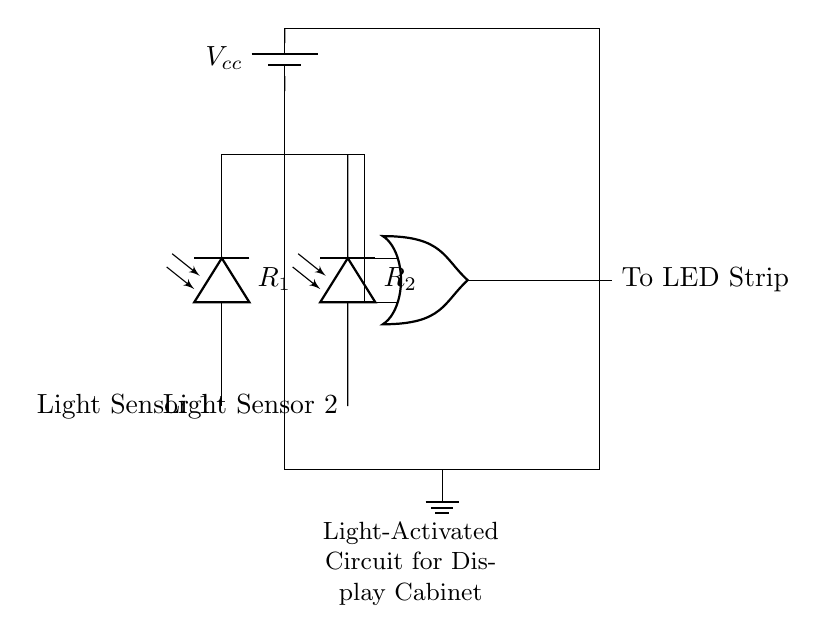What type of sensors are used in this circuit? The circuit uses two light sensors, which are illustrated by photodiodes labeled as Light Sensor 1 and Light Sensor 2. This can be seen in the left section of the diagram where the light sensors are connected to the OR gates.
Answer: photodiodes How many OR gates are in the circuit? The circuit contains one OR gate, which is represented in the center part of the diagram. It receives input from both light sensors.
Answer: one What is the role of the OR gate in this circuit? The OR gate combines the signals from the two light sensors. If either of the sensors detects light, it activates the output to the LED strip. This is a fundamental function of OR gates in logic.
Answer: combines signals What is the voltage source used in this circuit? The voltage source labeled as Vcc is provided by a battery indicated in the top part of the circuit diagram. It supplies power to the circuit components.
Answer: battery What happens when both light sensors are activated? When both light sensors are activated, the OR gate ensures that the output to the LED strip is still on since it only requires one active input to turn on. This exemplifies the behavior of an OR logical function.
Answer: LED strip lights up What is the output of the circuit connected to? The output of the OR gate connects to an LED strip, which is specified in the final part of the circuit diagram. The output shows where the light will be illuminated in the display cabinet.
Answer: LED strip What is the ground reference for this circuit? The ground reference is indicated at the bottom of the circuit diagram with a ground symbol, which serves as the common return path for current flow in the circuit.
Answer: ground 